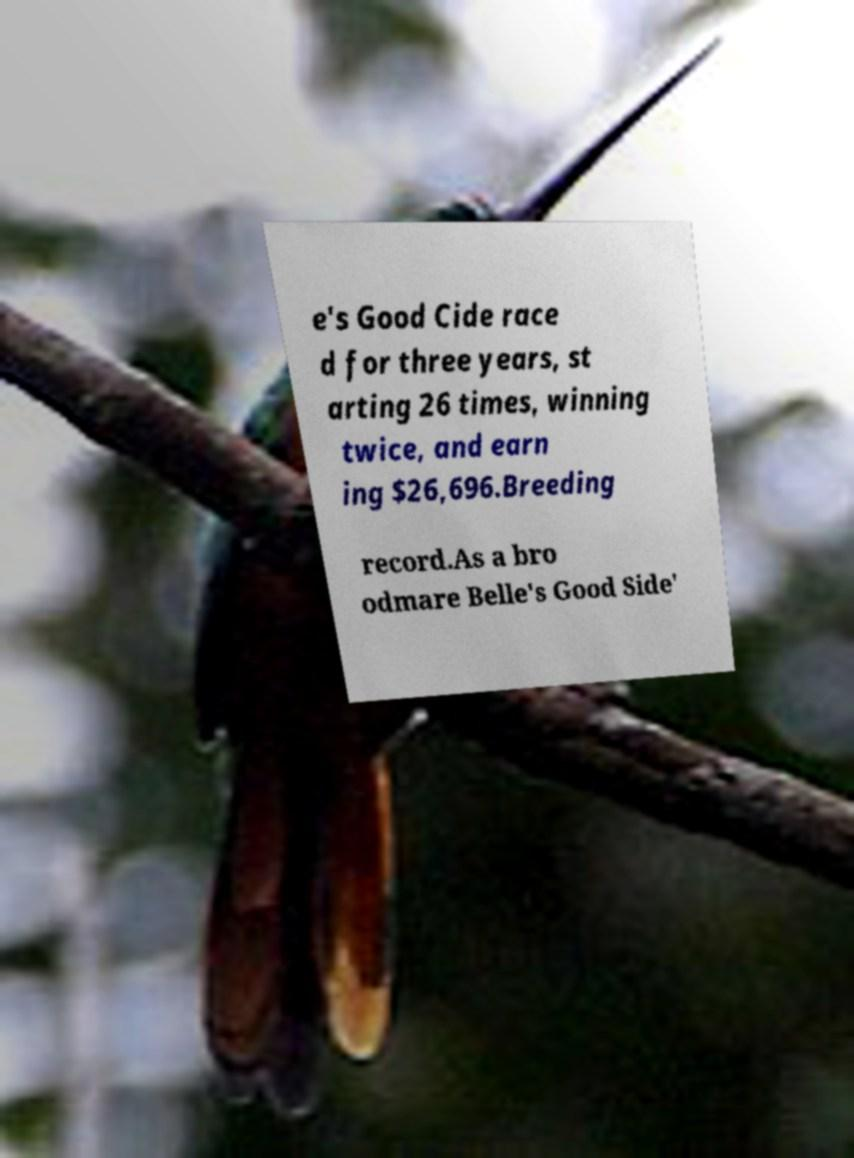Could you assist in decoding the text presented in this image and type it out clearly? e's Good Cide race d for three years, st arting 26 times, winning twice, and earn ing $26,696.Breeding record.As a bro odmare Belle's Good Side' 